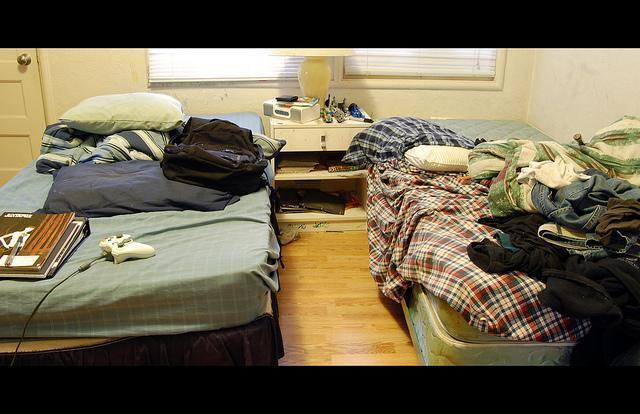How many beds are in the photo?
Give a very brief answer. 3. 